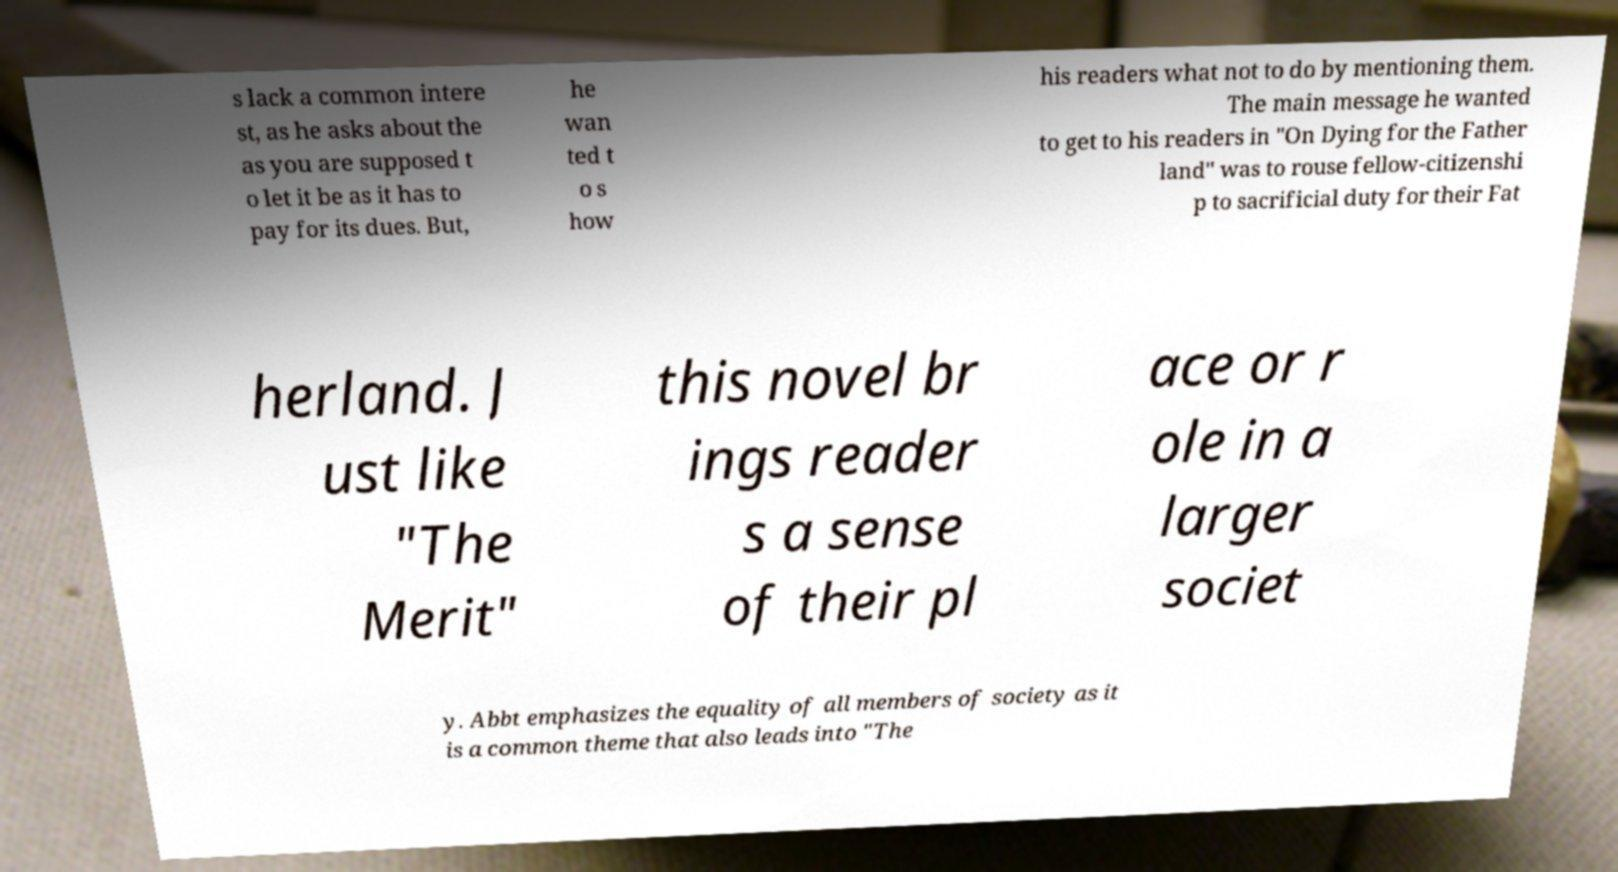Could you assist in decoding the text presented in this image and type it out clearly? s lack a common intere st, as he asks about the as you are supposed t o let it be as it has to pay for its dues. But, he wan ted t o s how his readers what not to do by mentioning them. The main message he wanted to get to his readers in "On Dying for the Father land" was to rouse fellow-citizenshi p to sacrificial duty for their Fat herland. J ust like "The Merit" this novel br ings reader s a sense of their pl ace or r ole in a larger societ y. Abbt emphasizes the equality of all members of society as it is a common theme that also leads into "The 